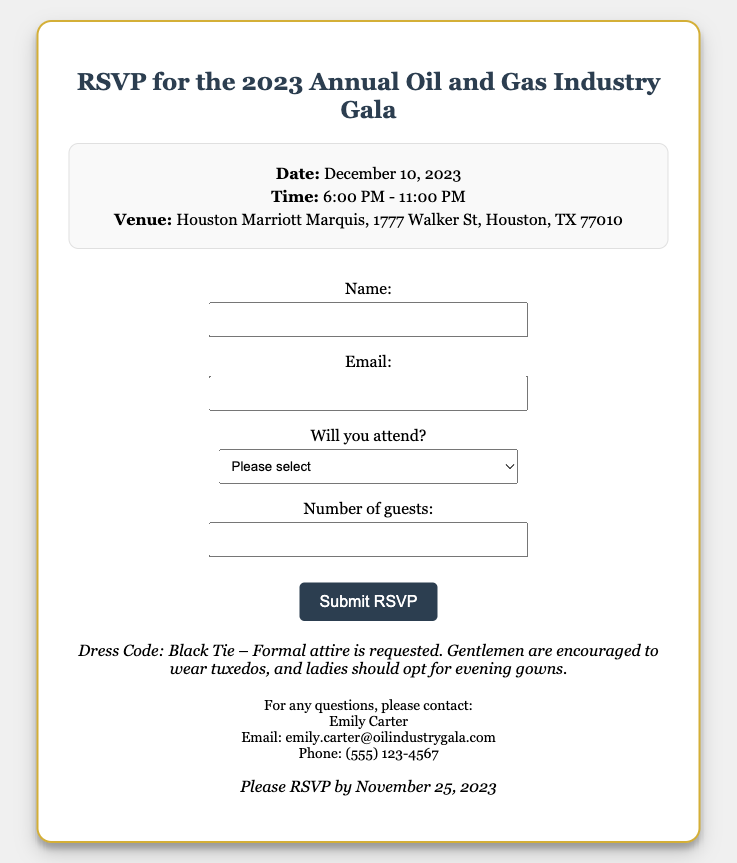what is the event date? The event date is clearly stated in the document under event details.
Answer: December 10, 2023 what time does the gala start? The start time is listed in the event details section of the document.
Answer: 6:00 PM what is the venue for the gala? The venue is provided in the event details of the RSVP card.
Answer: Houston Marriott Marquis, 1777 Walker St, Houston, TX 77010 what is the dress code for the event? The dress code is specified in the dress code section of the document.
Answer: Black Tie who should I contact for questions? The contact person's name and details are mentioned in the contact info section.
Answer: Emily Carter by what date should I RSVP? The RSVP deadline is indicated at the bottom of the document.
Answer: November 25, 2023 how many guests can I invite? The document specifies the number of guests allowed in the RSVP form section.
Answer: 2 is formal attire requested for the event? The dress code description clearly indicates the type of attire expected.
Answer: Yes 